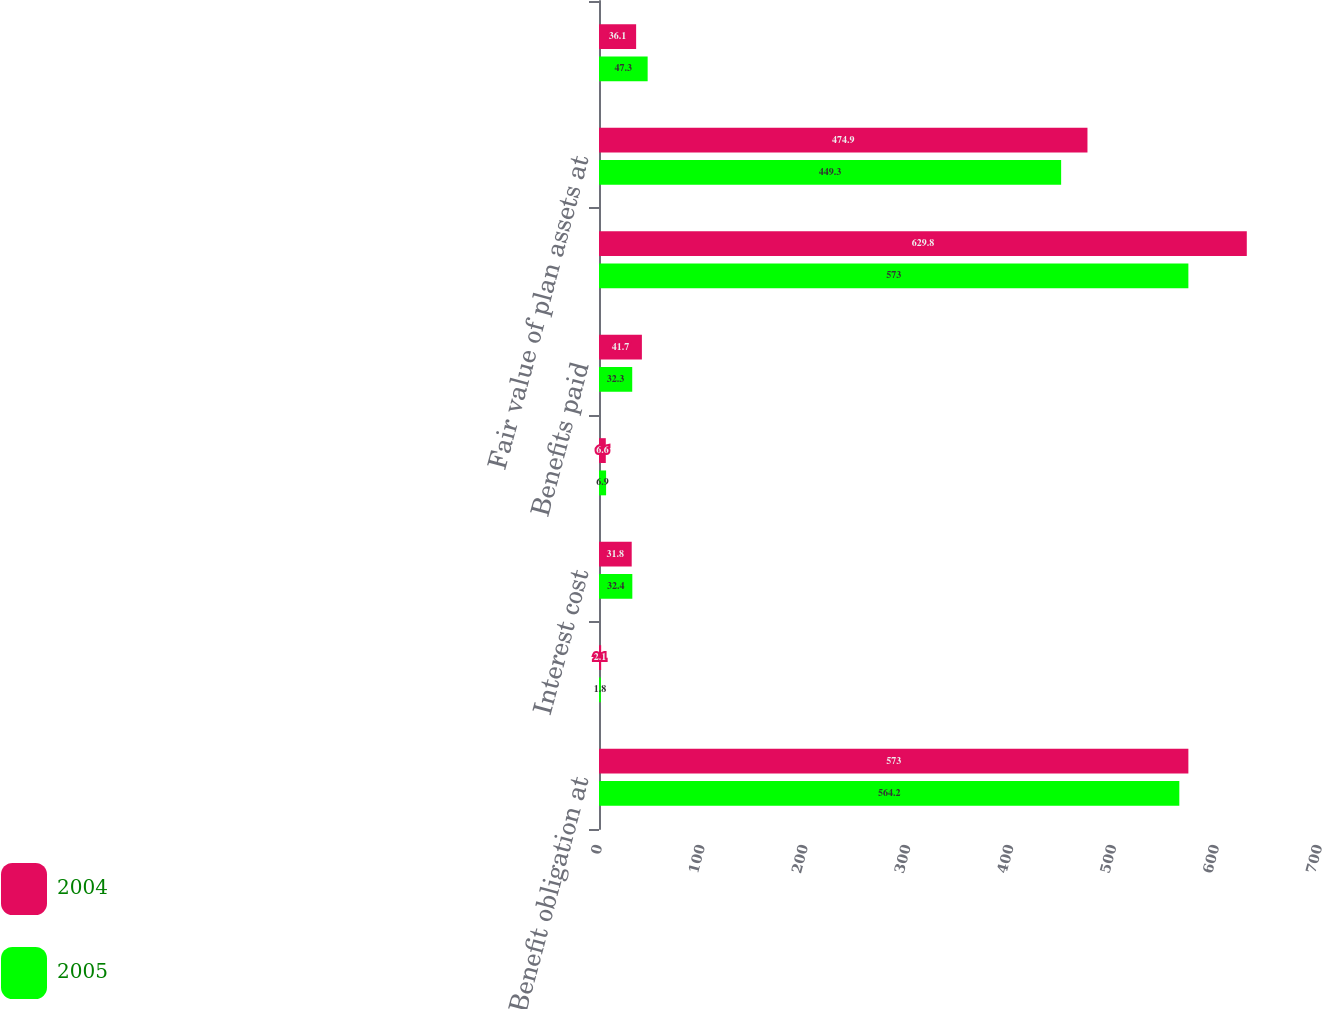Convert chart. <chart><loc_0><loc_0><loc_500><loc_500><stacked_bar_chart><ecel><fcel>Benefit obligation at<fcel>Service cost<fcel>Interest cost<fcel>Actuarial loss<fcel>Benefits paid<fcel>Benefit obligation at end of<fcel>Fair value of plan assets at<fcel>Actual return on plan assets<nl><fcel>2004<fcel>573<fcel>2.1<fcel>31.8<fcel>6.6<fcel>41.7<fcel>629.8<fcel>474.9<fcel>36.1<nl><fcel>2005<fcel>564.2<fcel>1.8<fcel>32.4<fcel>6.9<fcel>32.3<fcel>573<fcel>449.3<fcel>47.3<nl></chart> 